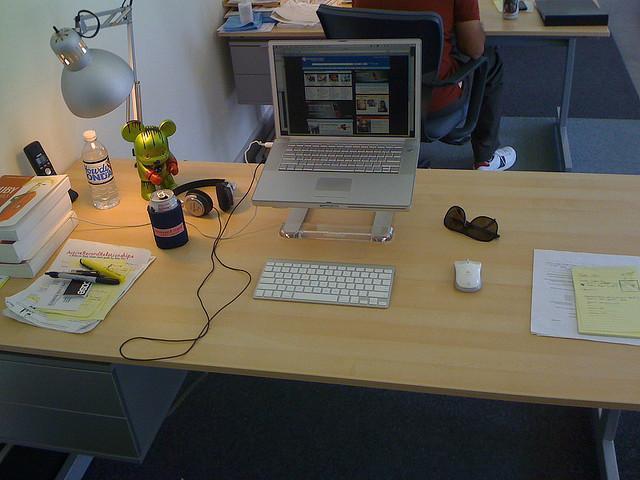How many keyboards can you see?
Give a very brief answer. 2. How many white remotes do you see?
Give a very brief answer. 0. 